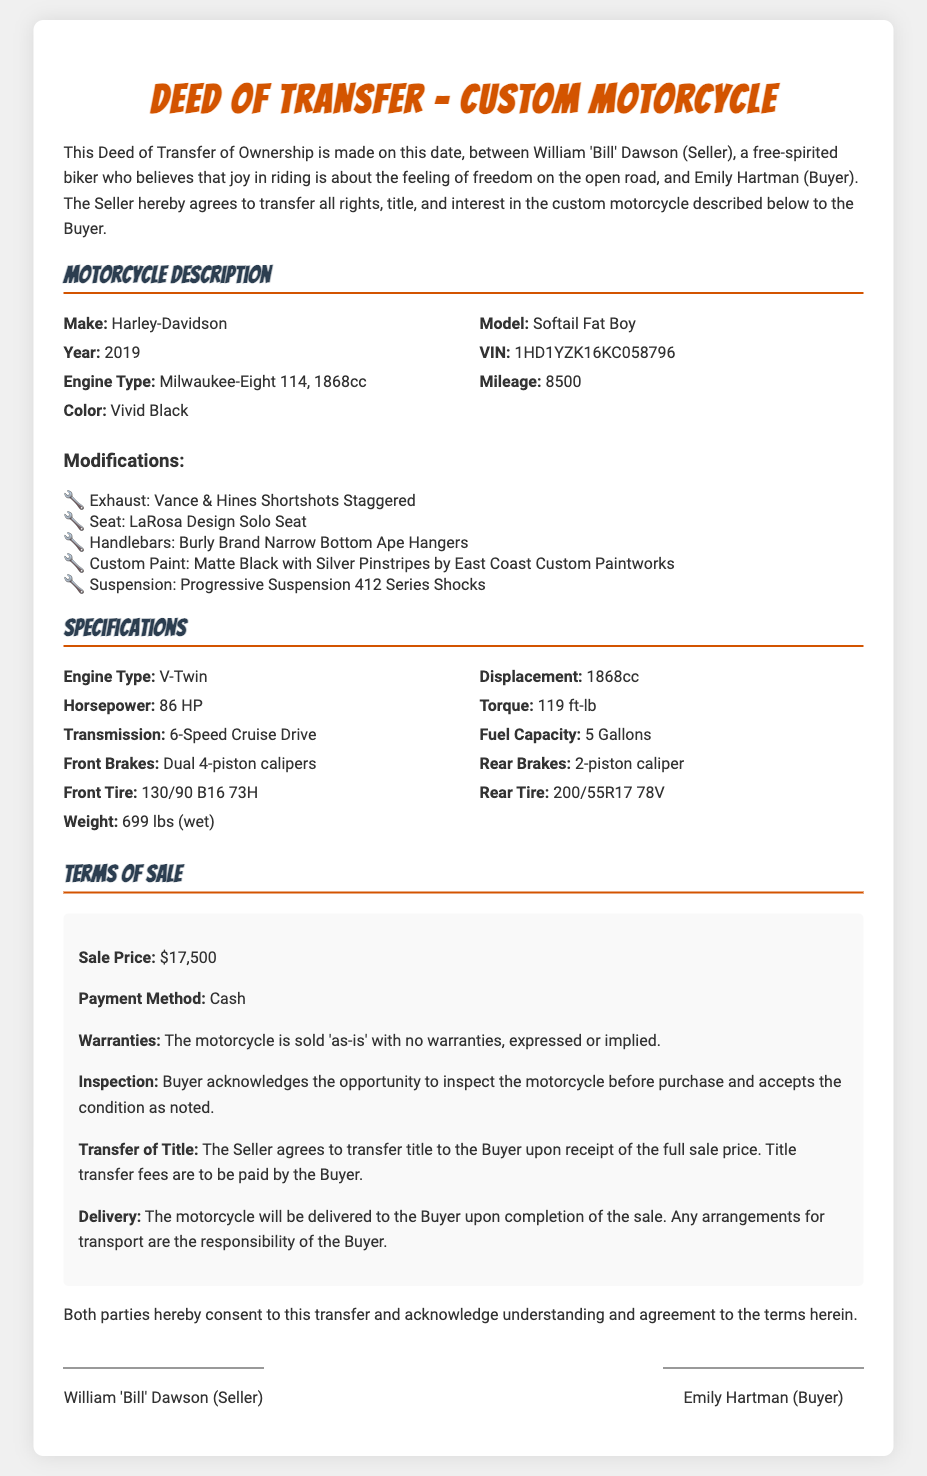What is the make of the motorcycle? The make of the motorcycle is explicitly stated in the document under Motorcycle Description.
Answer: Harley-Davidson What is the sale price? The sale price is mentioned clearly in the Terms of Sale section.
Answer: $17,500 Who is the buyer? The document identifies Emily Hartman as the Buyer in the introductory paragraph.
Answer: Emily Hartman What is the year of the motorcycle? The year of the motorcycle is listed in the Motorcycle Description section.
Answer: 2019 What type of engine does the motorcycle have? The engine type is specified in the Motorcycle Description, detailing its specifications.
Answer: Milwaukee-Eight 114 How many miles has the motorcycle been ridden? The mileage is recorded in the Motorcycle Description section of the document.
Answer: 8500 What modifications have been made to the motorcycle? The document lists modifications in a section specifically titled Modifications.
Answer: Various modifications including Vance & Hines Shortshots Staggered exhaust What are the payment terms? The payment terms are outlined in the Terms of Sale, indicating that payment is required.
Answer: Cash What responsibility does the buyer have for delivery? The Terms of Sale elaborate on the buyer's responsibilities for transport arrangements.
Answer: Responsibility of the Buyer 